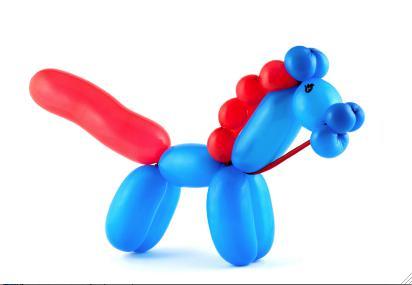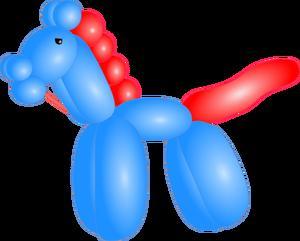The first image is the image on the left, the second image is the image on the right. Analyze the images presented: Is the assertion "At least one balloon has a string attached." valid? Answer yes or no. No. 